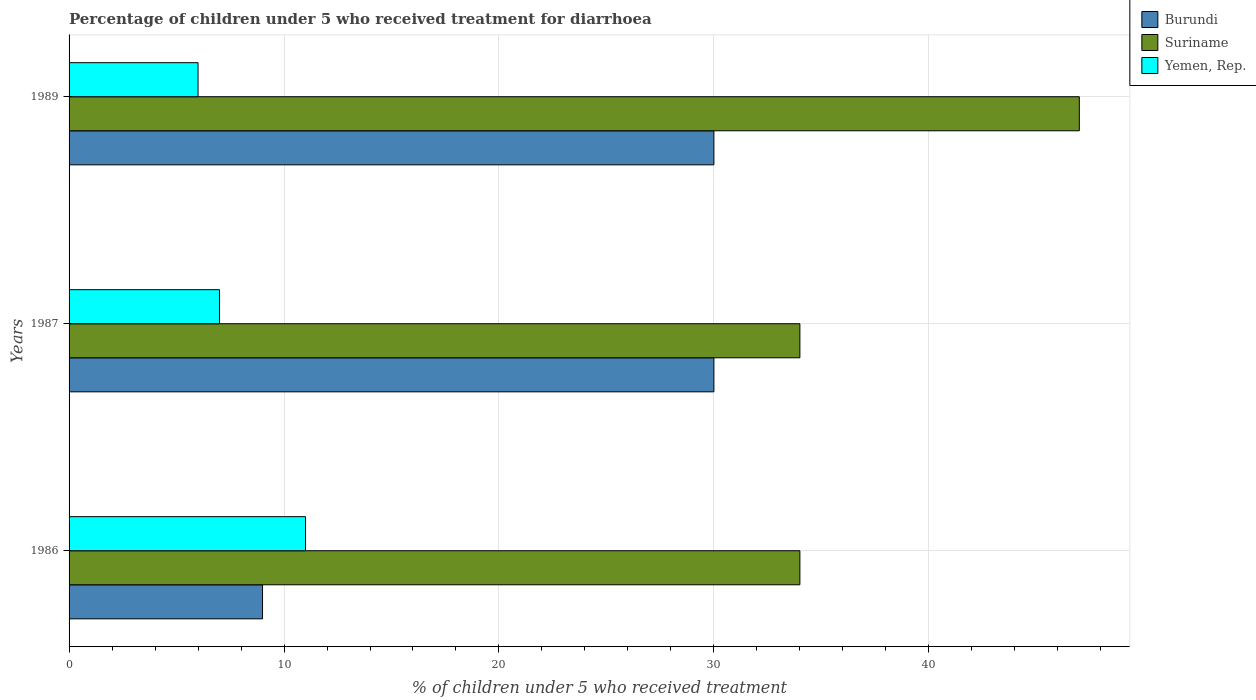How many different coloured bars are there?
Your response must be concise. 3. How many groups of bars are there?
Your response must be concise. 3. What is the label of the 3rd group of bars from the top?
Your response must be concise. 1986. In which year was the percentage of children who received treatment for diarrhoea  in Burundi minimum?
Your answer should be compact. 1986. What is the difference between the percentage of children who received treatment for diarrhoea  in Suriname in 1989 and the percentage of children who received treatment for diarrhoea  in Yemen, Rep. in 1986?
Offer a terse response. 36. What is the average percentage of children who received treatment for diarrhoea  in Suriname per year?
Offer a very short reply. 38.33. In the year 1989, what is the difference between the percentage of children who received treatment for diarrhoea  in Suriname and percentage of children who received treatment for diarrhoea  in Burundi?
Keep it short and to the point. 17. In how many years, is the percentage of children who received treatment for diarrhoea  in Burundi greater than 24 %?
Give a very brief answer. 2. What is the ratio of the percentage of children who received treatment for diarrhoea  in Burundi in 1986 to that in 1987?
Offer a very short reply. 0.3. Is the percentage of children who received treatment for diarrhoea  in Burundi in 1987 less than that in 1989?
Offer a terse response. No. What does the 1st bar from the top in 1989 represents?
Ensure brevity in your answer.  Yemen, Rep. What does the 2nd bar from the bottom in 1989 represents?
Ensure brevity in your answer.  Suriname. Are the values on the major ticks of X-axis written in scientific E-notation?
Offer a very short reply. No. Does the graph contain any zero values?
Ensure brevity in your answer.  No. Where does the legend appear in the graph?
Offer a terse response. Top right. How many legend labels are there?
Offer a very short reply. 3. What is the title of the graph?
Make the answer very short. Percentage of children under 5 who received treatment for diarrhoea. What is the label or title of the X-axis?
Your answer should be compact. % of children under 5 who received treatment. What is the label or title of the Y-axis?
Your answer should be very brief. Years. What is the % of children under 5 who received treatment in Suriname in 1986?
Provide a succinct answer. 34. What is the % of children under 5 who received treatment of Yemen, Rep. in 1986?
Provide a short and direct response. 11. What is the % of children under 5 who received treatment in Burundi in 1987?
Provide a succinct answer. 30. What is the % of children under 5 who received treatment of Suriname in 1987?
Your answer should be compact. 34. What is the % of children under 5 who received treatment of Burundi in 1989?
Your answer should be compact. 30. What is the % of children under 5 who received treatment in Suriname in 1989?
Give a very brief answer. 47. What is the % of children under 5 who received treatment in Yemen, Rep. in 1989?
Offer a very short reply. 6. Across all years, what is the minimum % of children under 5 who received treatment in Burundi?
Your answer should be compact. 9. Across all years, what is the minimum % of children under 5 who received treatment in Suriname?
Provide a short and direct response. 34. What is the total % of children under 5 who received treatment in Suriname in the graph?
Your answer should be very brief. 115. What is the total % of children under 5 who received treatment in Yemen, Rep. in the graph?
Provide a succinct answer. 24. What is the difference between the % of children under 5 who received treatment of Burundi in 1986 and that in 1987?
Your answer should be compact. -21. What is the difference between the % of children under 5 who received treatment in Burundi in 1986 and that in 1989?
Give a very brief answer. -21. What is the difference between the % of children under 5 who received treatment in Suriname in 1986 and that in 1989?
Give a very brief answer. -13. What is the difference between the % of children under 5 who received treatment in Suriname in 1987 and that in 1989?
Offer a very short reply. -13. What is the difference between the % of children under 5 who received treatment of Suriname in 1986 and the % of children under 5 who received treatment of Yemen, Rep. in 1987?
Provide a succinct answer. 27. What is the difference between the % of children under 5 who received treatment of Burundi in 1986 and the % of children under 5 who received treatment of Suriname in 1989?
Provide a short and direct response. -38. What is the difference between the % of children under 5 who received treatment of Burundi in 1986 and the % of children under 5 who received treatment of Yemen, Rep. in 1989?
Make the answer very short. 3. What is the difference between the % of children under 5 who received treatment in Suriname in 1986 and the % of children under 5 who received treatment in Yemen, Rep. in 1989?
Offer a very short reply. 28. What is the difference between the % of children under 5 who received treatment of Burundi in 1987 and the % of children under 5 who received treatment of Yemen, Rep. in 1989?
Your response must be concise. 24. What is the difference between the % of children under 5 who received treatment in Suriname in 1987 and the % of children under 5 who received treatment in Yemen, Rep. in 1989?
Your response must be concise. 28. What is the average % of children under 5 who received treatment in Burundi per year?
Give a very brief answer. 23. What is the average % of children under 5 who received treatment in Suriname per year?
Give a very brief answer. 38.33. What is the average % of children under 5 who received treatment of Yemen, Rep. per year?
Ensure brevity in your answer.  8. In the year 1986, what is the difference between the % of children under 5 who received treatment in Burundi and % of children under 5 who received treatment in Suriname?
Your answer should be very brief. -25. In the year 1986, what is the difference between the % of children under 5 who received treatment of Burundi and % of children under 5 who received treatment of Yemen, Rep.?
Make the answer very short. -2. In the year 1987, what is the difference between the % of children under 5 who received treatment of Burundi and % of children under 5 who received treatment of Suriname?
Your answer should be very brief. -4. In the year 1987, what is the difference between the % of children under 5 who received treatment in Burundi and % of children under 5 who received treatment in Yemen, Rep.?
Give a very brief answer. 23. In the year 1987, what is the difference between the % of children under 5 who received treatment in Suriname and % of children under 5 who received treatment in Yemen, Rep.?
Give a very brief answer. 27. In the year 1989, what is the difference between the % of children under 5 who received treatment of Burundi and % of children under 5 who received treatment of Suriname?
Your answer should be very brief. -17. In the year 1989, what is the difference between the % of children under 5 who received treatment of Suriname and % of children under 5 who received treatment of Yemen, Rep.?
Your answer should be very brief. 41. What is the ratio of the % of children under 5 who received treatment of Suriname in 1986 to that in 1987?
Provide a short and direct response. 1. What is the ratio of the % of children under 5 who received treatment in Yemen, Rep. in 1986 to that in 1987?
Offer a very short reply. 1.57. What is the ratio of the % of children under 5 who received treatment in Suriname in 1986 to that in 1989?
Keep it short and to the point. 0.72. What is the ratio of the % of children under 5 who received treatment of Yemen, Rep. in 1986 to that in 1989?
Provide a succinct answer. 1.83. What is the ratio of the % of children under 5 who received treatment in Burundi in 1987 to that in 1989?
Your answer should be very brief. 1. What is the ratio of the % of children under 5 who received treatment of Suriname in 1987 to that in 1989?
Give a very brief answer. 0.72. What is the difference between the highest and the second highest % of children under 5 who received treatment in Suriname?
Your answer should be compact. 13. What is the difference between the highest and the second highest % of children under 5 who received treatment of Yemen, Rep.?
Offer a very short reply. 4. What is the difference between the highest and the lowest % of children under 5 who received treatment in Burundi?
Offer a very short reply. 21. What is the difference between the highest and the lowest % of children under 5 who received treatment of Yemen, Rep.?
Your response must be concise. 5. 